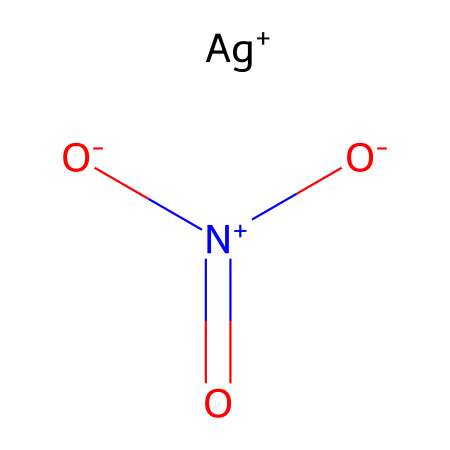What is the oxidation state of silver in this compound? The compound contains a silver ion represented as [Ag+], indicating it has a +1 oxidation state.
Answer: +1 How many oxygen atoms are present in silver nitrate? The chemical structure includes three oxygen atoms attached as part of the nitrate group, as indicated by the three O atoms in the SMILES representation.
Answer: 3 What type of bond exists between the silver ion and the nitrate group? The bond between the silver ion and the nitrate group is an ionic bond, as silver tends to lose its electron and form a positive ion, which interacts with the negatively charged nitrate ion.
Answer: ionic What is the total number of atoms in silver nitrate? Counting the atoms in the structure gives one silver (Ag), one nitrogen (N), and three oxygen (O) atoms, leading to a total of five atoms in the compound.
Answer: 5 What functional group is present in silver nitrate? The presence of the nitrogen atom directly bonded to three oxygens with one of them negatively charged indicates the presence of a nitrate functional group.
Answer: nitrate How many formal charges are present in this compound? In the chemical structure, silver has a +1 charge and the nitrate has a -1 charge. Therefore, the overall charge count yields no net charge (0).
Answer: 0 